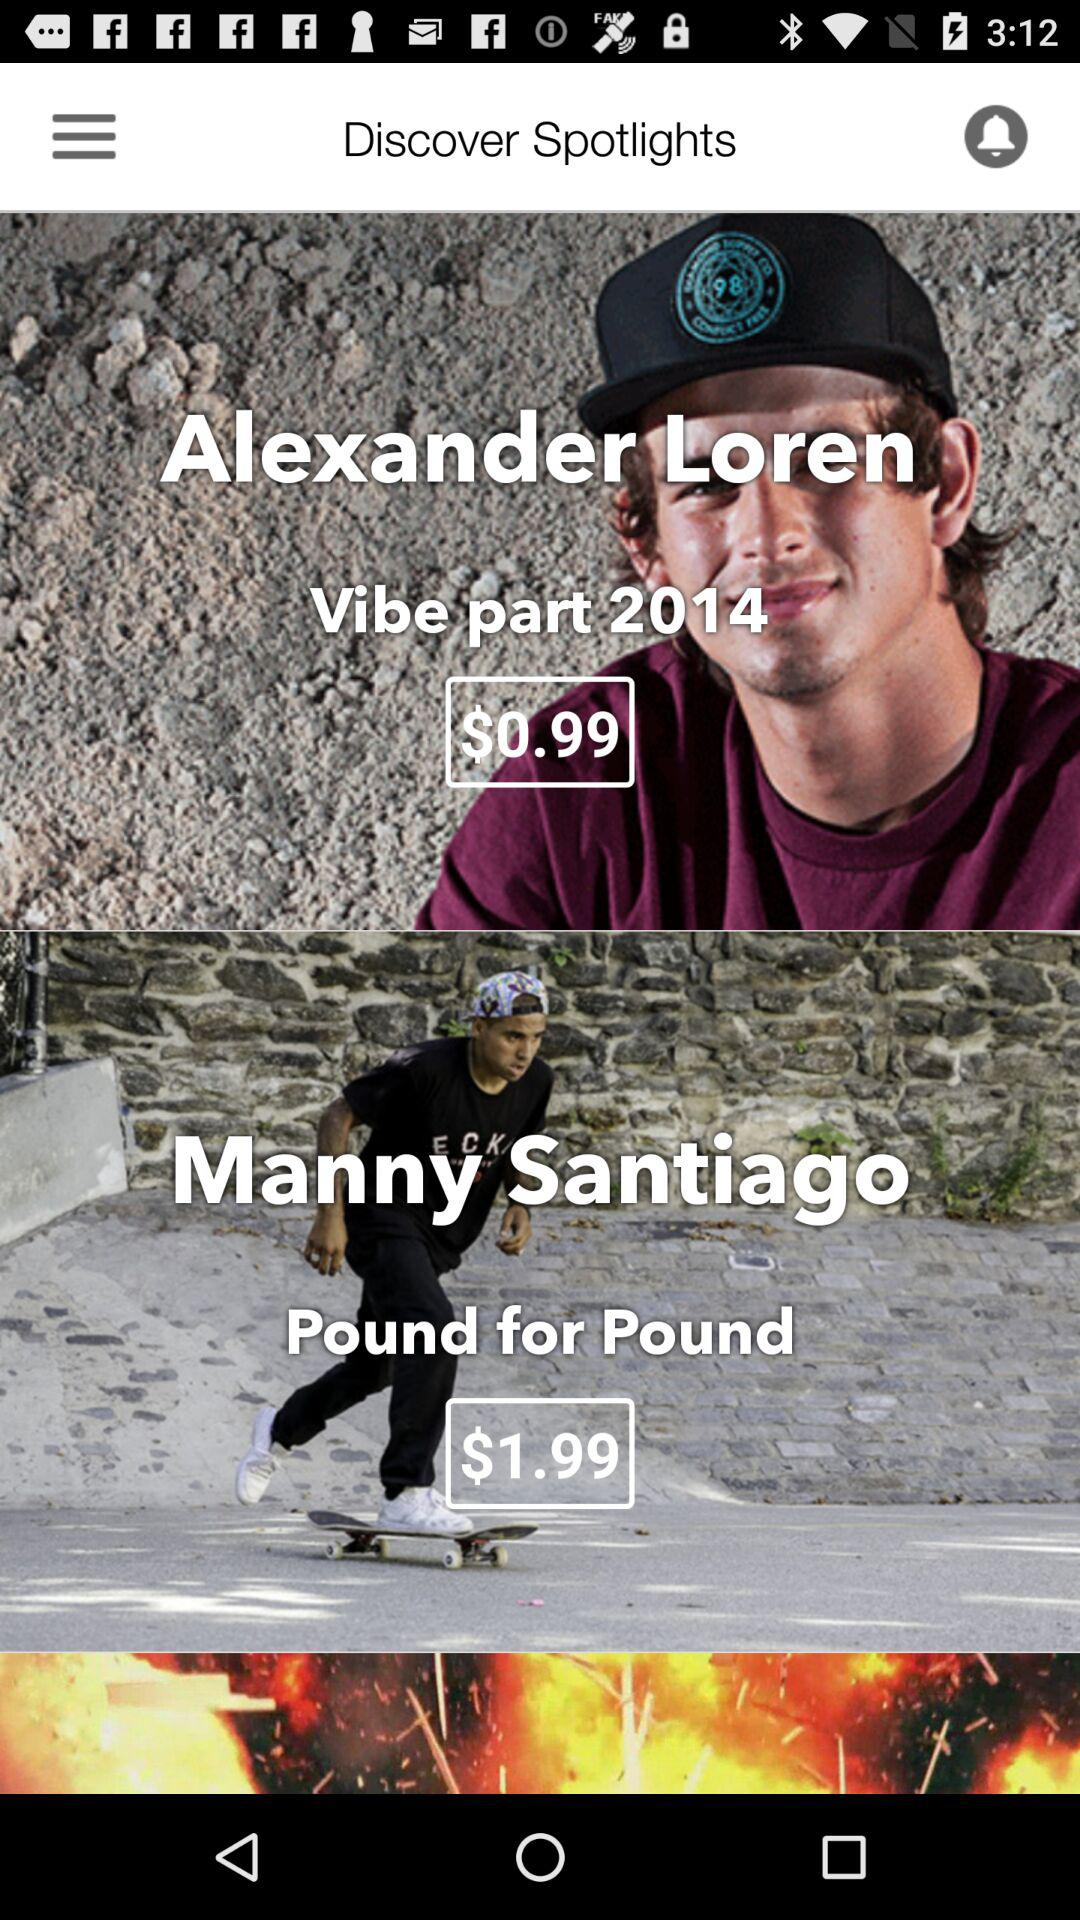How much does the Manny Santiago video cost in British pounds?
When the provided information is insufficient, respond with <no answer>. <no answer> 